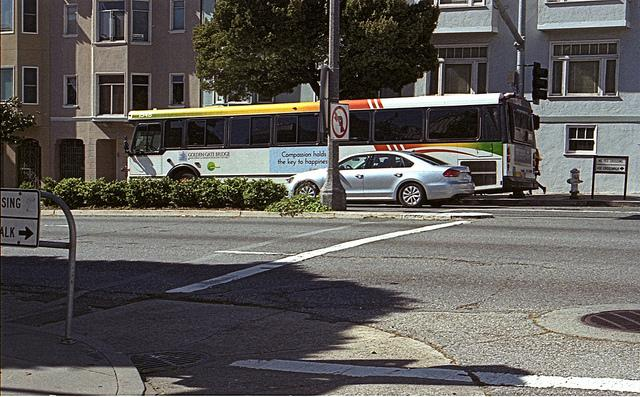What is the car next to? bus 